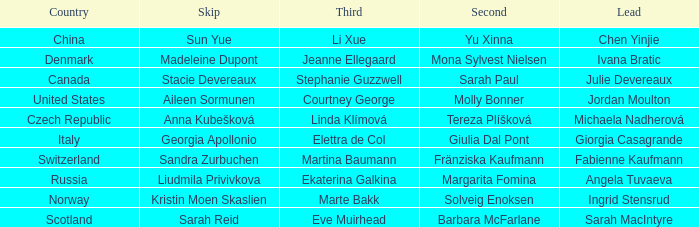What skip has norway as the country? Kristin Moen Skaslien. 